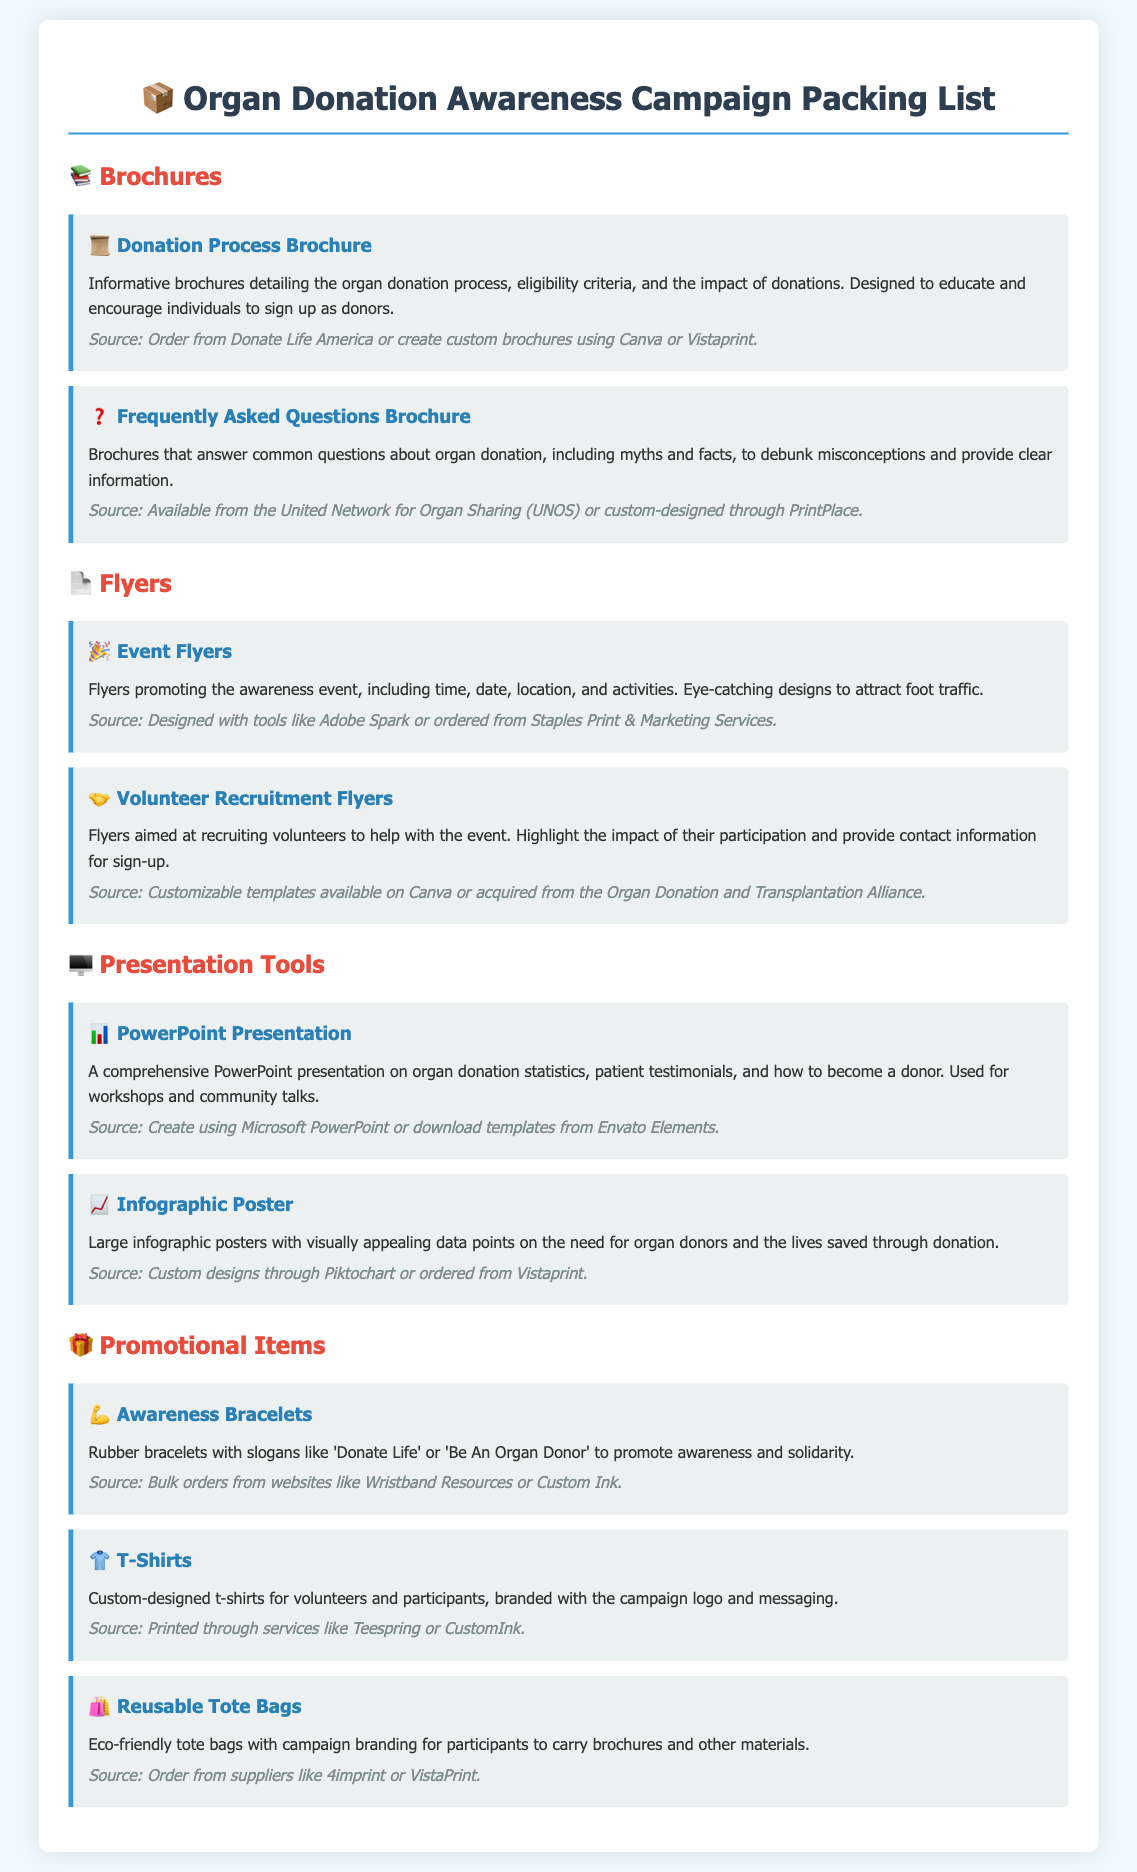What type of brochures are included in the packing list? The packing list includes informative brochures detailing the organ donation process and FAQs about organ donation.
Answer: Donation Process Brochure and Frequently Asked Questions Brochure Where can you obtain Donation Process Brochures? The source provided in the document mentions where to order these brochures.
Answer: Donate Life America or create custom brochures using Canva or Vistaprint What promotional item features slogans like 'Donate Life'? The packing list states that there are rubber bracelets with these slogans.
Answer: Awareness Bracelets How many presentation tools are mentioned in the document? The document lists two presentation tools specifically.
Answer: Two Which tool can be used for creating an infographic poster? The document mentions a specific tool that allows for creating infographic posters.
Answer: Piktochart How could you design event flyers? The packing list suggests specific design tools for creating event flyers.
Answer: Adobe Spark What kind of T-shirts are listed in the packing list? The packing list specifies the type of T-shirts being ordered.
Answer: Custom-designed t-shirts for volunteers and participants What is the purpose of volunteer recruitment flyers? The document explains the main aim of these flyers.
Answer: Recruiting volunteers to help with the event 